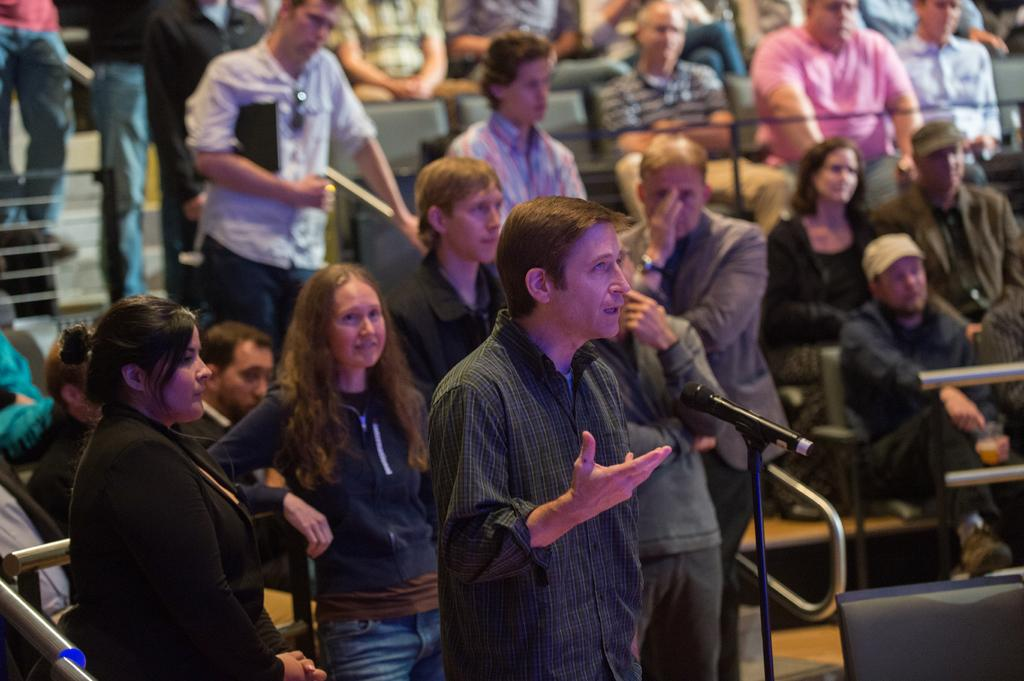What are the people in the image doing? Some people are standing on the stairs, while others are sitting on chairs. Is there any interaction between the people and an object in the image? Yes, one person is speaking into a microphone placed on the floor. Can you see a rat in the image? No, there is no rat present in the image. Are the people in the image kissing? There is no indication of kissing in the image. 